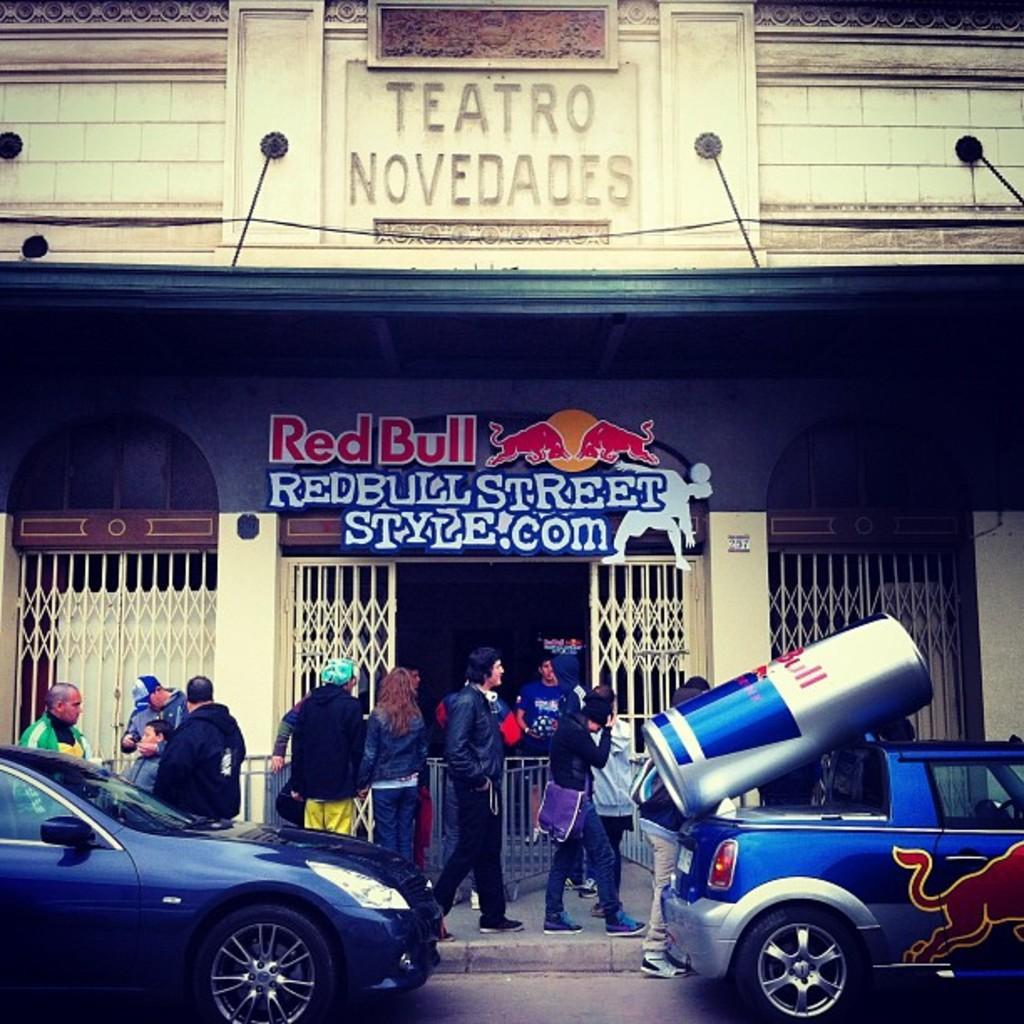Describe this image in one or two sentences. In this image we can see the building which includes text written on the board, beside that we can see a few people walking, at the bottom we can see vehicles on the road. 